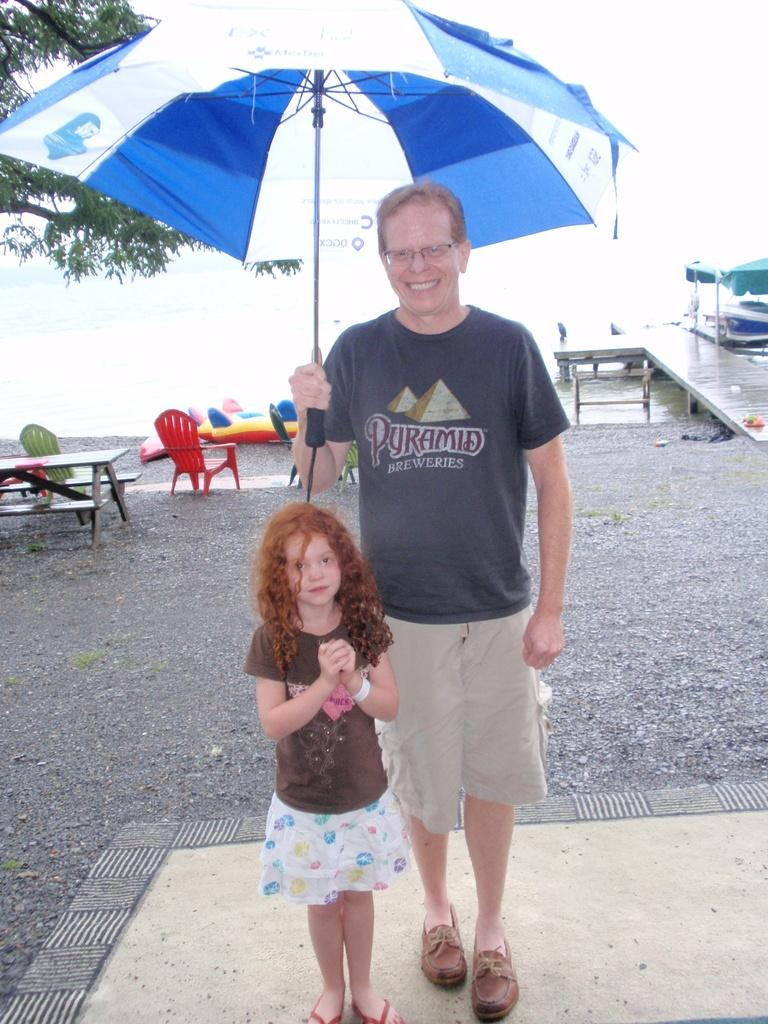Who is present in the image? There is a man and a child in the image. What is the man holding in the image? The man is holding an umbrella in the image. What type of furniture can be seen in the image? There is a table and chairs in the image. What can be seen in the background of the image? There is a tree visible in the image. What type of ornament is hanging from the child's ear in the image? There is no ornament hanging from the child's ear in the image. How many potatoes can be seen on the table in the image? There are no potatoes present in the image. 